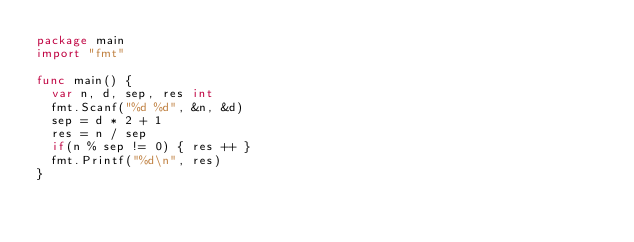Convert code to text. <code><loc_0><loc_0><loc_500><loc_500><_Go_>package main
import "fmt"
 
func main() {
  var n, d, sep, res int
  fmt.Scanf("%d %d", &n, &d)
  sep = d * 2 + 1
  res = n / sep
  if(n % sep != 0) { res ++ }
  fmt.Printf("%d\n", res)
}</code> 